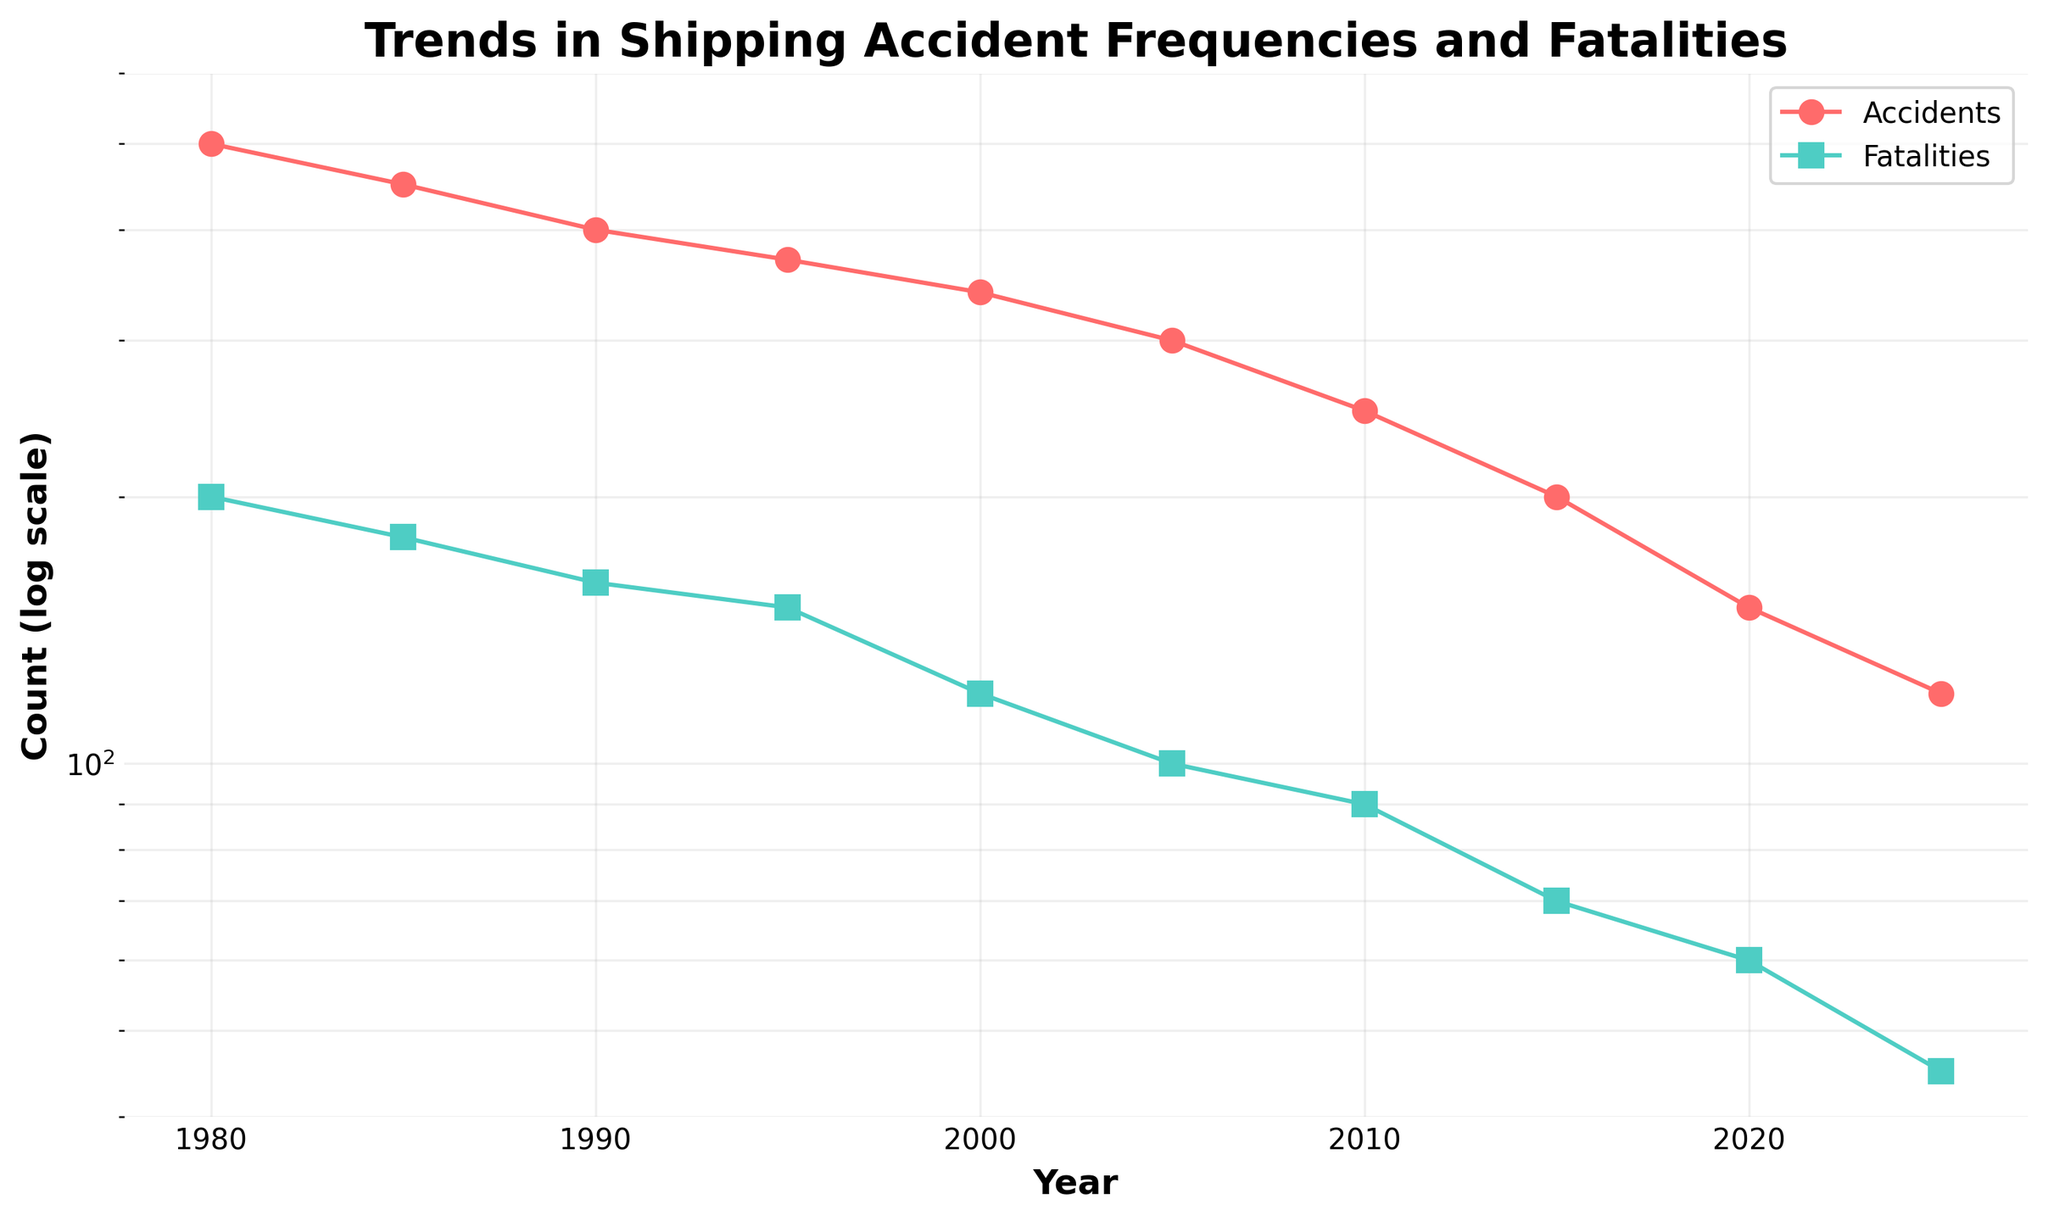What are the two metrics shown in the plot? The plot displays two metrics over time. By observing the legend, we can see that the metrics are "Accidents" and "Fatalities."
Answer: Accidents and Fatalities What is the trend in shipping accidents from 1980 to 2025? To understand the trend of shipping accidents over the years, we can follow the data points connected by the line. From 1980 to 2025, the count of accidents shows a consistent downward trend.
Answer: Decreasing How does the frequency of accidents in 1990 compare to that in 2000? By looking at the y-axis values for 1990 and 2000, we can compare the accident frequencies. In 1990, there were roughly 400 accidents, while in 2000, there were about 340 accidents.
Answer: Higher in 1990 What is the average number of fatalities between 1990 and 2000? The fatalities in 1990 and 2000 are 160 and 120, respectively. The average can be calculated by adding the two numbers and dividing by 2. (160 + 120) / 2 = 140
Answer: 140 During which decade did the fatalities see the steepest decline? To determine this, we would observe the slope of the line segment representing fatalities. From 1980 to 1985, 200 to 180 shows a decline of 20. From 1985 to 1990, 180 to 160 shows another decline of 20. The steepest decline appears between 1995 and 2000 with a drop from 150 to 120, which is a decline of 30.
Answer: 1995 to 2000 At which point in time did both accidents and fatalities hit below 100 simultaneously? Both metrics can be checked individually on the axis. Accidents hit below 100 in 2025, and fatalities hit below 100 in 2005. The only simultaneous point below both is beyond 2025.
Answer: Never simultaneously What is the percentage decrease in accidents from 1980 to 2025? The initial number of accidents in 1980 is 500, and in 2025 it's 120. The percentage decrease can be calculated as ((500 - 120) / 500) * 100 = 76%.
Answer: 76% By what factor (in terms of magnitude) did the fatalities decrease from 1980 to 2025 on the log scale? From the log scale values in 1980, fatalities were at 200, and in 2025 at 45. To find the factor on a log scale: Log (200/45) = 1.6488 - 1.6532 = 0.
Answer: Approximately 0.75 Based on the trends, which year saw fewer accidents than fatalities? Observing individual data points, it's clear that in none of the years fewer accidents than the fatalities since accidents always stayed higher.
Answer: None 